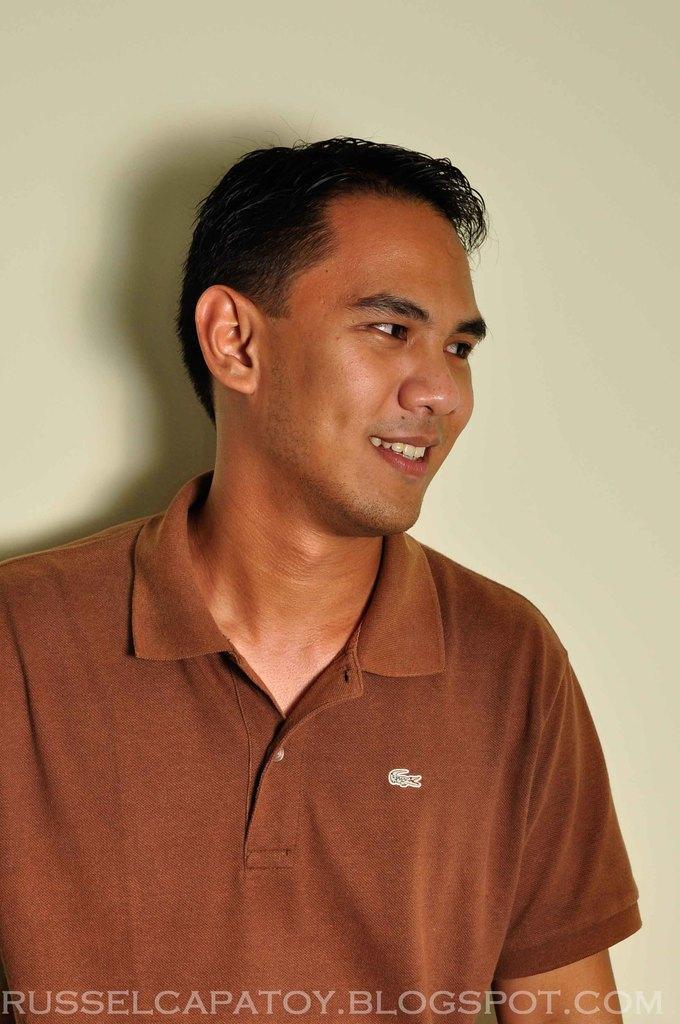Can you describe this image briefly? In this picture there is a man smiling, behind him we can see wall. At the bottom of the image we can see text. 